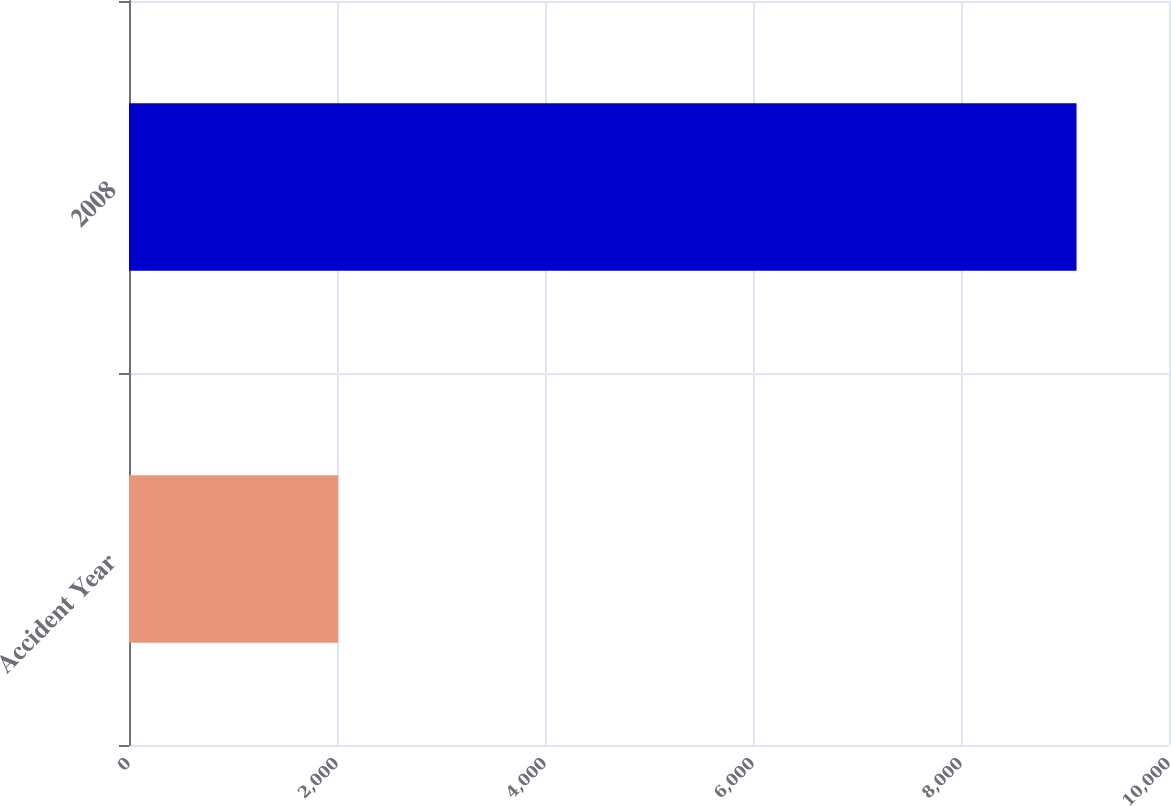Convert chart to OTSL. <chart><loc_0><loc_0><loc_500><loc_500><bar_chart><fcel>Accident Year<fcel>2008<nl><fcel>2011<fcel>9111<nl></chart> 